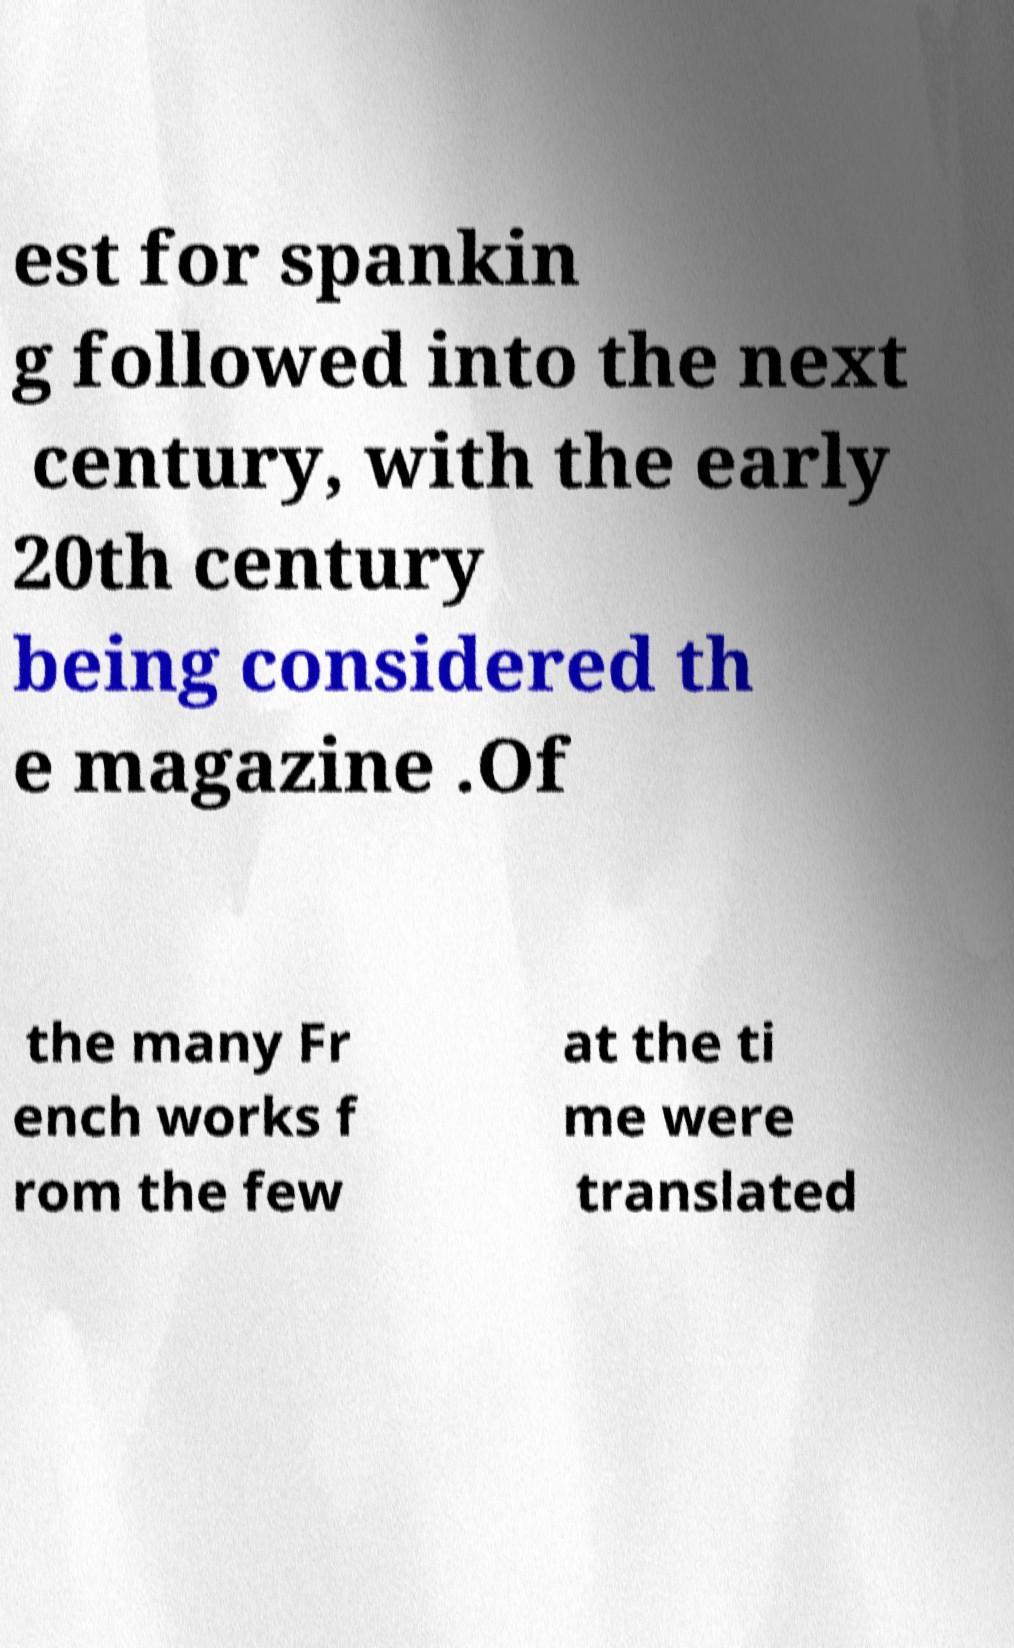Could you assist in decoding the text presented in this image and type it out clearly? est for spankin g followed into the next century, with the early 20th century being considered th e magazine .Of the many Fr ench works f rom the few at the ti me were translated 